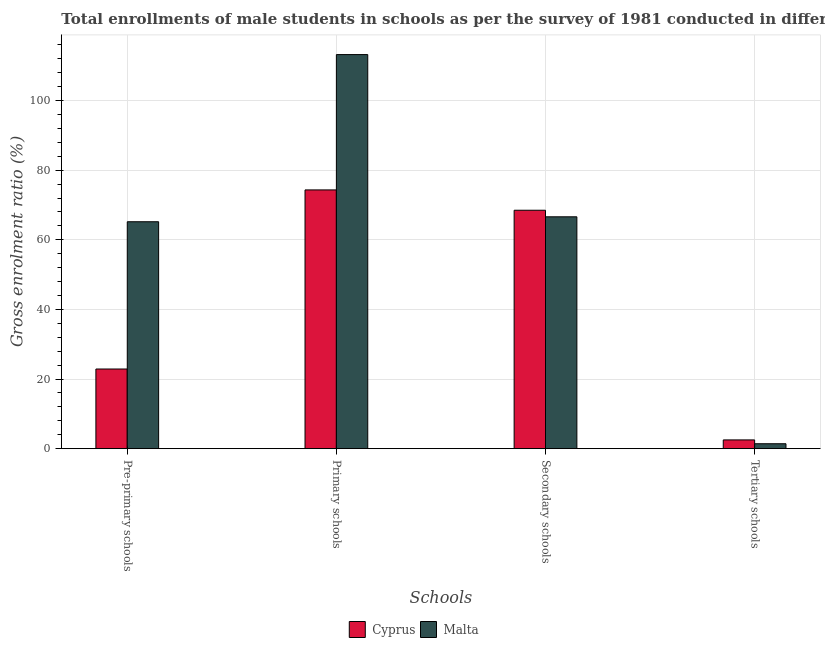How many different coloured bars are there?
Your answer should be compact. 2. Are the number of bars per tick equal to the number of legend labels?
Your answer should be very brief. Yes. Are the number of bars on each tick of the X-axis equal?
Ensure brevity in your answer.  Yes. How many bars are there on the 4th tick from the left?
Provide a short and direct response. 2. How many bars are there on the 2nd tick from the right?
Your answer should be very brief. 2. What is the label of the 3rd group of bars from the left?
Provide a short and direct response. Secondary schools. What is the gross enrolment ratio(male) in primary schools in Cyprus?
Offer a terse response. 74.33. Across all countries, what is the maximum gross enrolment ratio(male) in secondary schools?
Keep it short and to the point. 68.49. Across all countries, what is the minimum gross enrolment ratio(male) in tertiary schools?
Give a very brief answer. 1.42. In which country was the gross enrolment ratio(male) in tertiary schools maximum?
Offer a terse response. Cyprus. In which country was the gross enrolment ratio(male) in primary schools minimum?
Your answer should be very brief. Cyprus. What is the total gross enrolment ratio(male) in secondary schools in the graph?
Your answer should be very brief. 135.09. What is the difference between the gross enrolment ratio(male) in tertiary schools in Malta and that in Cyprus?
Make the answer very short. -1.1. What is the difference between the gross enrolment ratio(male) in primary schools in Cyprus and the gross enrolment ratio(male) in pre-primary schools in Malta?
Give a very brief answer. 9.14. What is the average gross enrolment ratio(male) in tertiary schools per country?
Give a very brief answer. 1.97. What is the difference between the gross enrolment ratio(male) in primary schools and gross enrolment ratio(male) in pre-primary schools in Cyprus?
Provide a short and direct response. 51.44. What is the ratio of the gross enrolment ratio(male) in pre-primary schools in Malta to that in Cyprus?
Offer a very short reply. 2.85. Is the difference between the gross enrolment ratio(male) in pre-primary schools in Cyprus and Malta greater than the difference between the gross enrolment ratio(male) in tertiary schools in Cyprus and Malta?
Your response must be concise. No. What is the difference between the highest and the second highest gross enrolment ratio(male) in tertiary schools?
Ensure brevity in your answer.  1.1. What is the difference between the highest and the lowest gross enrolment ratio(male) in primary schools?
Provide a short and direct response. 38.87. Is the sum of the gross enrolment ratio(male) in pre-primary schools in Malta and Cyprus greater than the maximum gross enrolment ratio(male) in primary schools across all countries?
Give a very brief answer. No. Is it the case that in every country, the sum of the gross enrolment ratio(male) in secondary schools and gross enrolment ratio(male) in pre-primary schools is greater than the sum of gross enrolment ratio(male) in primary schools and gross enrolment ratio(male) in tertiary schools?
Your answer should be compact. Yes. What does the 2nd bar from the left in Tertiary schools represents?
Give a very brief answer. Malta. What does the 1st bar from the right in Secondary schools represents?
Your response must be concise. Malta. Does the graph contain any zero values?
Your answer should be very brief. No. How are the legend labels stacked?
Provide a short and direct response. Horizontal. What is the title of the graph?
Your response must be concise. Total enrollments of male students in schools as per the survey of 1981 conducted in different countries. Does "Luxembourg" appear as one of the legend labels in the graph?
Give a very brief answer. No. What is the label or title of the X-axis?
Ensure brevity in your answer.  Schools. What is the label or title of the Y-axis?
Offer a terse response. Gross enrolment ratio (%). What is the Gross enrolment ratio (%) in Cyprus in Pre-primary schools?
Your response must be concise. 22.88. What is the Gross enrolment ratio (%) in Malta in Pre-primary schools?
Ensure brevity in your answer.  65.18. What is the Gross enrolment ratio (%) in Cyprus in Primary schools?
Your answer should be compact. 74.33. What is the Gross enrolment ratio (%) of Malta in Primary schools?
Give a very brief answer. 113.2. What is the Gross enrolment ratio (%) of Cyprus in Secondary schools?
Give a very brief answer. 68.49. What is the Gross enrolment ratio (%) of Malta in Secondary schools?
Offer a terse response. 66.6. What is the Gross enrolment ratio (%) of Cyprus in Tertiary schools?
Offer a terse response. 2.52. What is the Gross enrolment ratio (%) in Malta in Tertiary schools?
Your answer should be very brief. 1.42. Across all Schools, what is the maximum Gross enrolment ratio (%) in Cyprus?
Give a very brief answer. 74.33. Across all Schools, what is the maximum Gross enrolment ratio (%) of Malta?
Provide a succinct answer. 113.2. Across all Schools, what is the minimum Gross enrolment ratio (%) in Cyprus?
Provide a succinct answer. 2.52. Across all Schools, what is the minimum Gross enrolment ratio (%) in Malta?
Make the answer very short. 1.42. What is the total Gross enrolment ratio (%) of Cyprus in the graph?
Your response must be concise. 168.22. What is the total Gross enrolment ratio (%) in Malta in the graph?
Your answer should be very brief. 246.4. What is the difference between the Gross enrolment ratio (%) in Cyprus in Pre-primary schools and that in Primary schools?
Offer a terse response. -51.44. What is the difference between the Gross enrolment ratio (%) in Malta in Pre-primary schools and that in Primary schools?
Offer a very short reply. -48.02. What is the difference between the Gross enrolment ratio (%) of Cyprus in Pre-primary schools and that in Secondary schools?
Provide a short and direct response. -45.61. What is the difference between the Gross enrolment ratio (%) of Malta in Pre-primary schools and that in Secondary schools?
Your answer should be compact. -1.42. What is the difference between the Gross enrolment ratio (%) of Cyprus in Pre-primary schools and that in Tertiary schools?
Provide a succinct answer. 20.36. What is the difference between the Gross enrolment ratio (%) of Malta in Pre-primary schools and that in Tertiary schools?
Make the answer very short. 63.76. What is the difference between the Gross enrolment ratio (%) of Cyprus in Primary schools and that in Secondary schools?
Your answer should be compact. 5.84. What is the difference between the Gross enrolment ratio (%) in Malta in Primary schools and that in Secondary schools?
Offer a terse response. 46.6. What is the difference between the Gross enrolment ratio (%) of Cyprus in Primary schools and that in Tertiary schools?
Your answer should be very brief. 71.81. What is the difference between the Gross enrolment ratio (%) of Malta in Primary schools and that in Tertiary schools?
Provide a short and direct response. 111.78. What is the difference between the Gross enrolment ratio (%) in Cyprus in Secondary schools and that in Tertiary schools?
Provide a short and direct response. 65.97. What is the difference between the Gross enrolment ratio (%) in Malta in Secondary schools and that in Tertiary schools?
Make the answer very short. 65.18. What is the difference between the Gross enrolment ratio (%) of Cyprus in Pre-primary schools and the Gross enrolment ratio (%) of Malta in Primary schools?
Provide a succinct answer. -90.32. What is the difference between the Gross enrolment ratio (%) in Cyprus in Pre-primary schools and the Gross enrolment ratio (%) in Malta in Secondary schools?
Your answer should be compact. -43.72. What is the difference between the Gross enrolment ratio (%) in Cyprus in Pre-primary schools and the Gross enrolment ratio (%) in Malta in Tertiary schools?
Provide a succinct answer. 21.46. What is the difference between the Gross enrolment ratio (%) of Cyprus in Primary schools and the Gross enrolment ratio (%) of Malta in Secondary schools?
Give a very brief answer. 7.73. What is the difference between the Gross enrolment ratio (%) in Cyprus in Primary schools and the Gross enrolment ratio (%) in Malta in Tertiary schools?
Your response must be concise. 72.91. What is the difference between the Gross enrolment ratio (%) in Cyprus in Secondary schools and the Gross enrolment ratio (%) in Malta in Tertiary schools?
Make the answer very short. 67.07. What is the average Gross enrolment ratio (%) of Cyprus per Schools?
Give a very brief answer. 42.05. What is the average Gross enrolment ratio (%) of Malta per Schools?
Ensure brevity in your answer.  61.6. What is the difference between the Gross enrolment ratio (%) in Cyprus and Gross enrolment ratio (%) in Malta in Pre-primary schools?
Your answer should be very brief. -42.3. What is the difference between the Gross enrolment ratio (%) of Cyprus and Gross enrolment ratio (%) of Malta in Primary schools?
Give a very brief answer. -38.87. What is the difference between the Gross enrolment ratio (%) of Cyprus and Gross enrolment ratio (%) of Malta in Secondary schools?
Offer a very short reply. 1.89. What is the difference between the Gross enrolment ratio (%) in Cyprus and Gross enrolment ratio (%) in Malta in Tertiary schools?
Keep it short and to the point. 1.1. What is the ratio of the Gross enrolment ratio (%) of Cyprus in Pre-primary schools to that in Primary schools?
Your response must be concise. 0.31. What is the ratio of the Gross enrolment ratio (%) in Malta in Pre-primary schools to that in Primary schools?
Keep it short and to the point. 0.58. What is the ratio of the Gross enrolment ratio (%) of Cyprus in Pre-primary schools to that in Secondary schools?
Ensure brevity in your answer.  0.33. What is the ratio of the Gross enrolment ratio (%) of Malta in Pre-primary schools to that in Secondary schools?
Provide a short and direct response. 0.98. What is the ratio of the Gross enrolment ratio (%) of Cyprus in Pre-primary schools to that in Tertiary schools?
Keep it short and to the point. 9.08. What is the ratio of the Gross enrolment ratio (%) in Malta in Pre-primary schools to that in Tertiary schools?
Keep it short and to the point. 45.96. What is the ratio of the Gross enrolment ratio (%) of Cyprus in Primary schools to that in Secondary schools?
Make the answer very short. 1.09. What is the ratio of the Gross enrolment ratio (%) of Malta in Primary schools to that in Secondary schools?
Offer a terse response. 1.7. What is the ratio of the Gross enrolment ratio (%) of Cyprus in Primary schools to that in Tertiary schools?
Your answer should be compact. 29.51. What is the ratio of the Gross enrolment ratio (%) of Malta in Primary schools to that in Tertiary schools?
Provide a short and direct response. 79.82. What is the ratio of the Gross enrolment ratio (%) of Cyprus in Secondary schools to that in Tertiary schools?
Your answer should be very brief. 27.19. What is the ratio of the Gross enrolment ratio (%) in Malta in Secondary schools to that in Tertiary schools?
Your answer should be very brief. 46.96. What is the difference between the highest and the second highest Gross enrolment ratio (%) in Cyprus?
Your response must be concise. 5.84. What is the difference between the highest and the second highest Gross enrolment ratio (%) in Malta?
Keep it short and to the point. 46.6. What is the difference between the highest and the lowest Gross enrolment ratio (%) of Cyprus?
Ensure brevity in your answer.  71.81. What is the difference between the highest and the lowest Gross enrolment ratio (%) of Malta?
Offer a terse response. 111.78. 